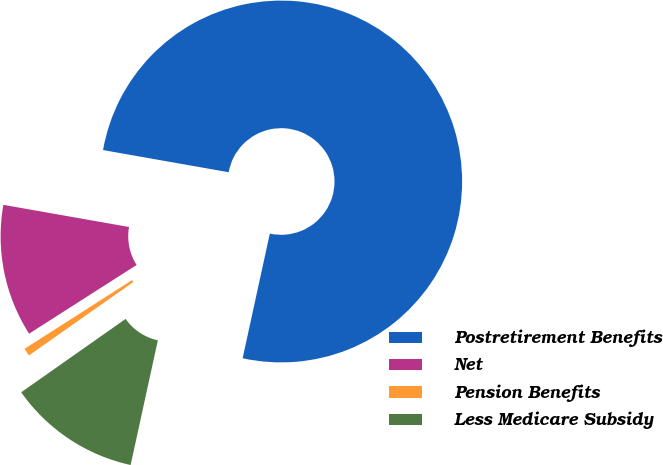Convert chart. <chart><loc_0><loc_0><loc_500><loc_500><pie_chart><fcel>Postretirement Benefits<fcel>Net<fcel>Pension Benefits<fcel>Less Medicare Subsidy<nl><fcel>75.64%<fcel>11.83%<fcel>0.7%<fcel>11.83%<nl></chart> 